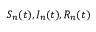<formula> <loc_0><loc_0><loc_500><loc_500>S _ { n } ( t ) , I _ { n } ( t ) , R _ { n } ( t )</formula> 